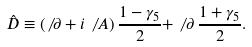<formula> <loc_0><loc_0><loc_500><loc_500>\hat { D } \equiv ( \not \, \partial + i \not \, A ) \, \frac { 1 - \gamma _ { 5 } } { 2 } + \not \, \partial \, \frac { 1 + \gamma _ { 5 } } { 2 } .</formula> 